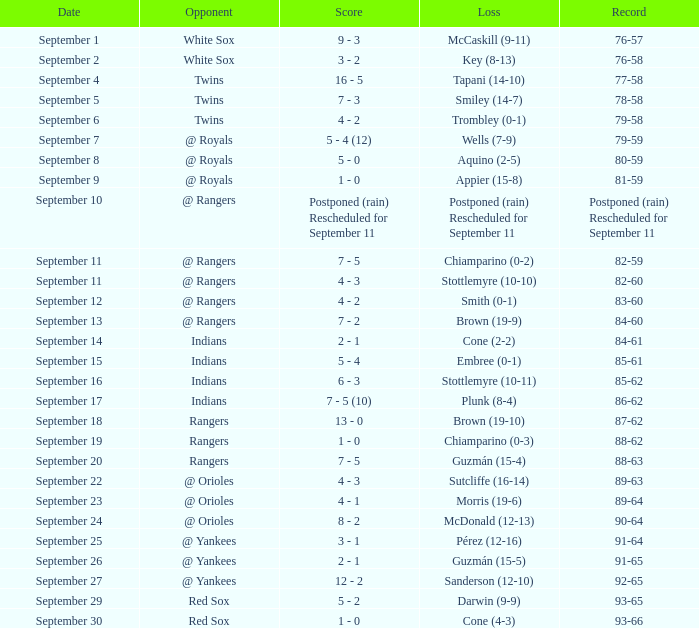What's the loss for September 16? Stottlemyre (10-11). 